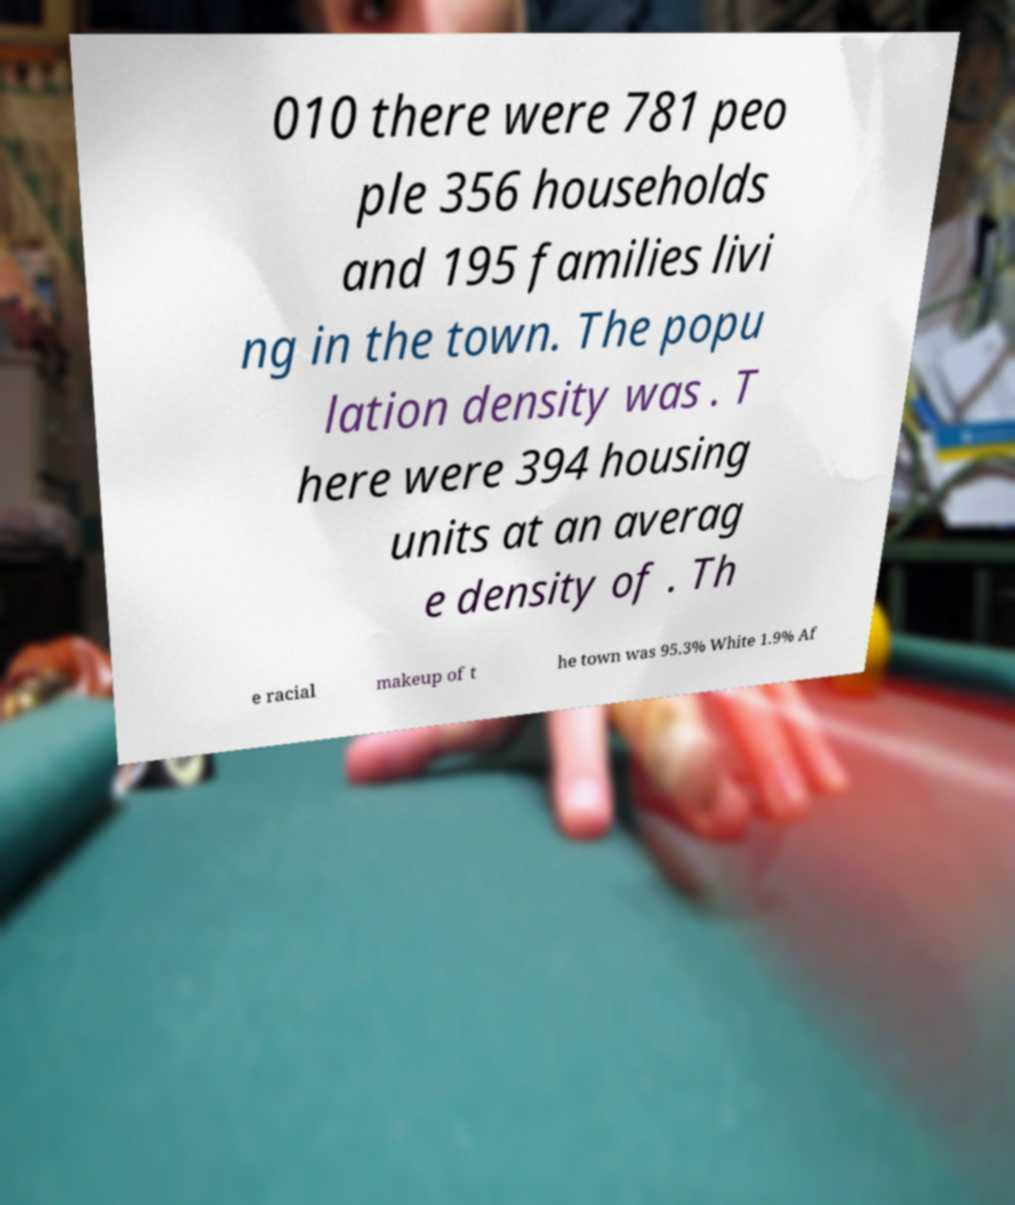For documentation purposes, I need the text within this image transcribed. Could you provide that? 010 there were 781 peo ple 356 households and 195 families livi ng in the town. The popu lation density was . T here were 394 housing units at an averag e density of . Th e racial makeup of t he town was 95.3% White 1.9% Af 